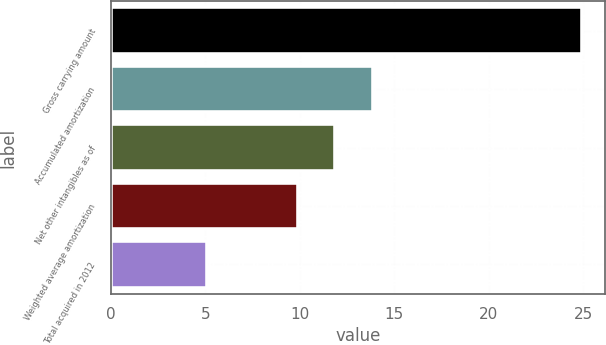Convert chart to OTSL. <chart><loc_0><loc_0><loc_500><loc_500><bar_chart><fcel>Gross carrying amount<fcel>Accumulated amortization<fcel>Net other intangibles as of<fcel>Weighted average amortization<fcel>Total acquired in 2012<nl><fcel>24.9<fcel>13.86<fcel>11.88<fcel>9.9<fcel>5.1<nl></chart> 